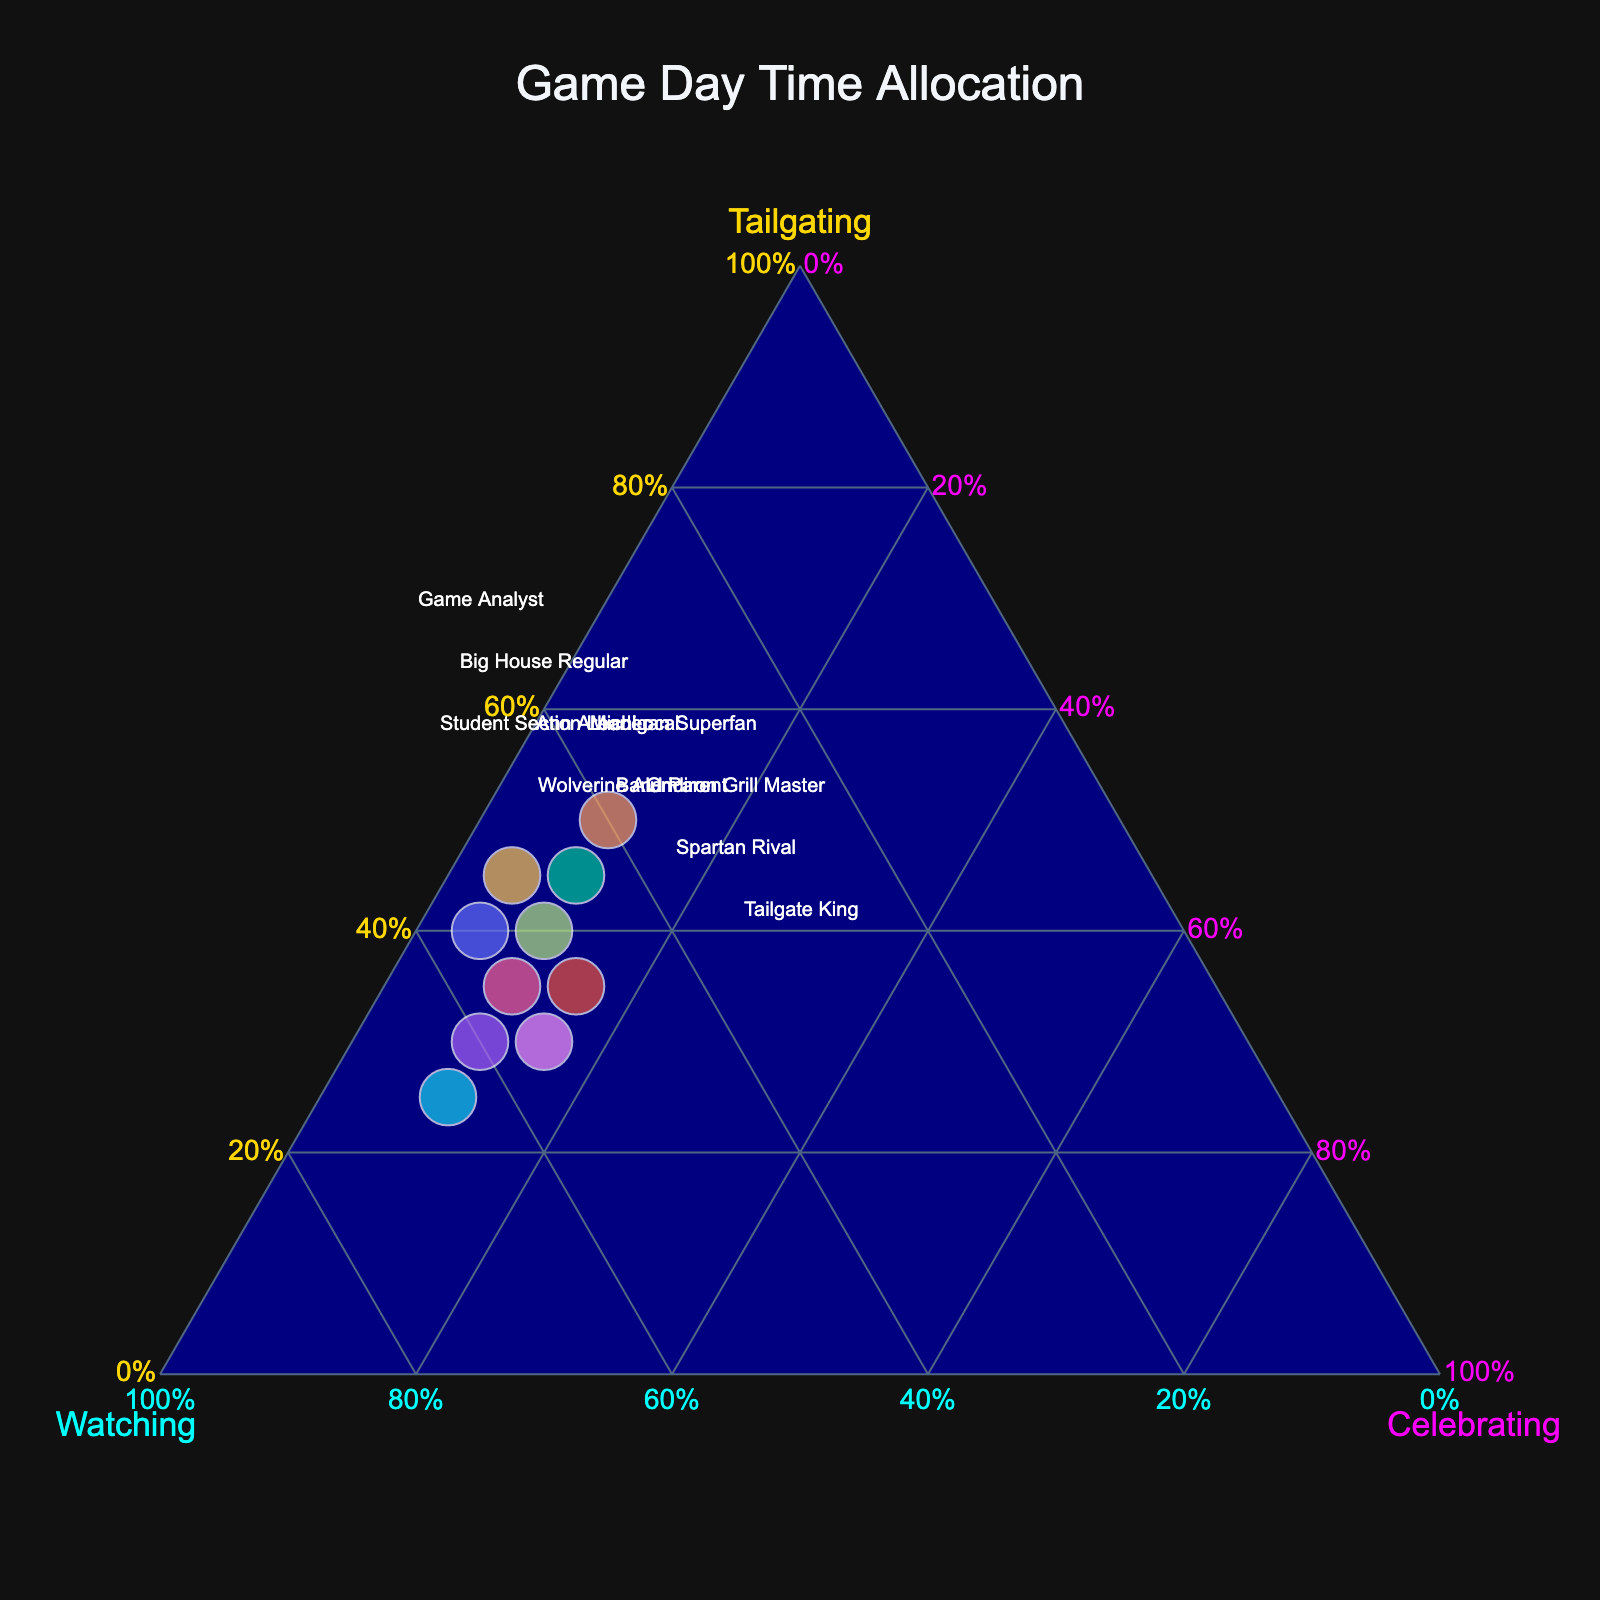What is the title of the plot? The title is prominently displayed at the top center of the plot.
Answer: Game Day Time Allocation How many fans are included in the plot? By counting the labels or hover texts, you can see there are 10 fans listed.
Answer: 10 Which fan spent the most time tailgating? The position of each point relative to the tailgating axis (left triangle edge) indicates the allocation. The point farthest from the opposite axis represents the highest value.
Answer: Tailgate King What is the color of the Watching axis? The axis colors are provided in the layout description.
Answer: Cyan Which fan has the highest percentage for Celebrating? The position of each point relative to the Celebrating axis (right edge of the triangle) indicates the allocation. Look for the point furthest from the tailgating axis.
Answer: Wolverine Alum & Student Section Leader How do Michigan Superfan and Gridiron Grill Master compare in terms of Watching time? Michigan Superfan and Gridiron Grill Master both have 50% watching time, indicated by their positions on the Watching axis.
Answer: Equal Who spends more time tailgating, Michigan Superfan, or Band Parent? By comparing their positions on the tailgating axis, Michigan Superfan (40%) is higher than Band Parent (35%), showing more time tailgating.
Answer: Michigan Superfan What's the average time spent celebrating among all fans? Add up the celebrating percentages: 5 + 15 + 10 + 10 + 10 + 10 + 10 + 10 + 15 + 5 = 100. Divide by number of fans (10).
Answer: 10% Which fan is closest to having an equal distribution of time across all three activities? Look for the point roughly at the center of the ternary plot where all three axes intersect.
Answer: Spartan Rival 